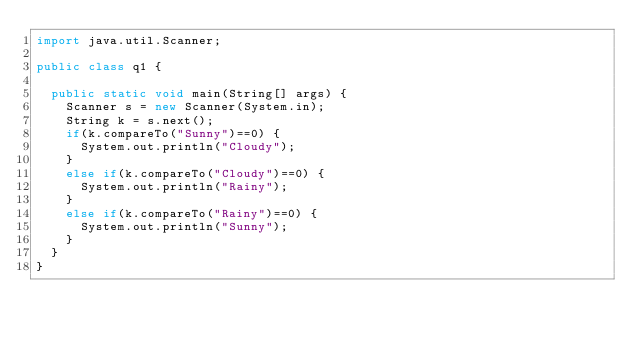<code> <loc_0><loc_0><loc_500><loc_500><_Java_>import java.util.Scanner;

public class q1 {

	public static void main(String[] args) {
		Scanner s = new Scanner(System.in);
		String k = s.next();
		if(k.compareTo("Sunny")==0) {
			System.out.println("Cloudy");
		}
		else if(k.compareTo("Cloudy")==0) {
			System.out.println("Rainy");
		}
		else if(k.compareTo("Rainy")==0) {
			System.out.println("Sunny");
		}
	}
}
</code> 